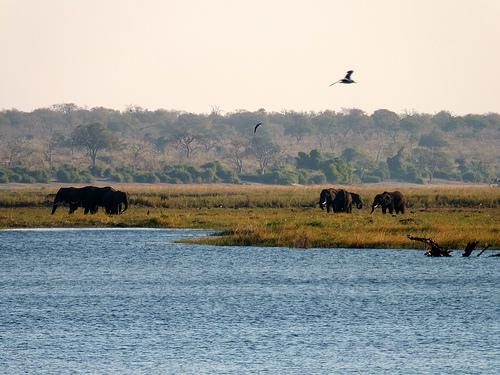Question: how many elephants are there?
Choices:
A. One.
B. Two.
C. Three.
D. Five.
Answer with the letter. Answer: D Question: what animals are there?
Choices:
A. Hippos.
B. Elephants.
C. Giraffes.
D. Zebras.
Answer with the letter. Answer: B Question: what is flying over the elephants?
Choices:
A. Bird.
B. Plane.
C. Helicopter.
D. Superman.
Answer with the letter. Answer: A Question: where are the animals at?
Choices:
A. Zoo.
B. Grassy field.
C. Cage.
D. Rocks.
Answer with the letter. Answer: B 